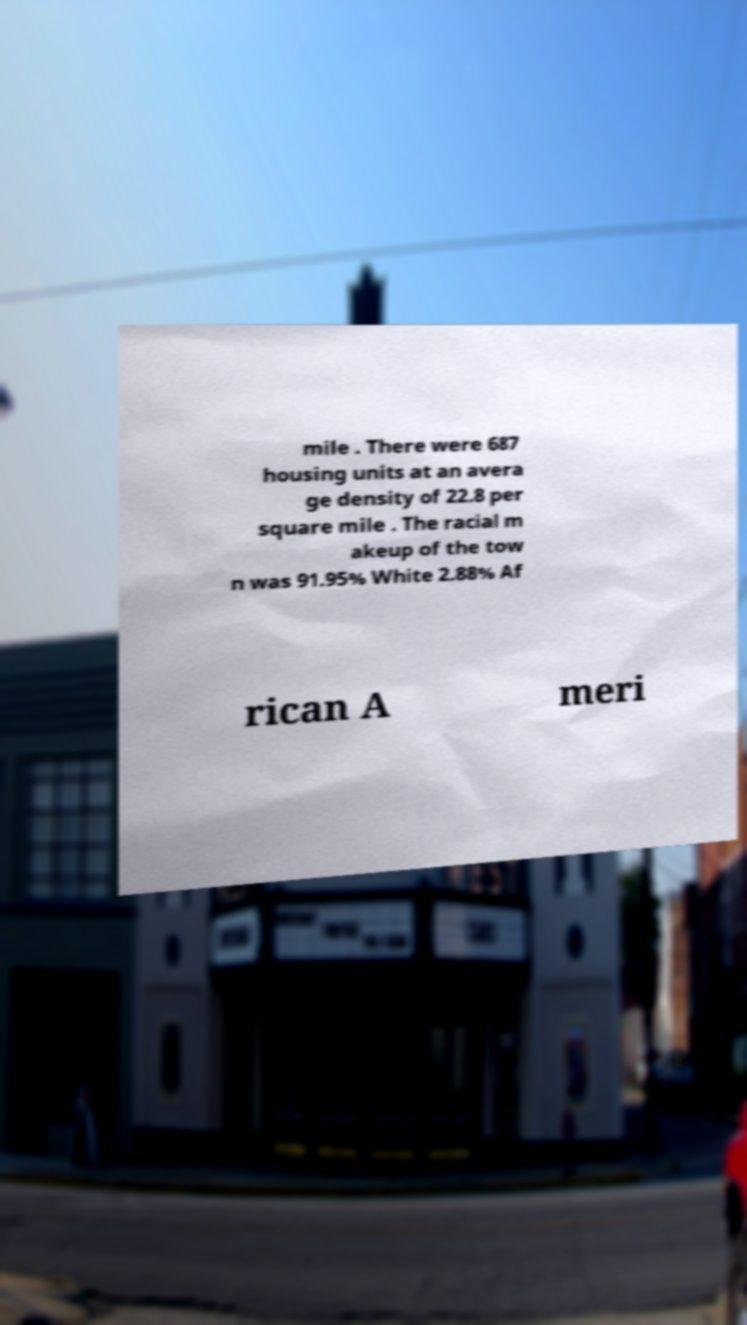Please read and relay the text visible in this image. What does it say? mile . There were 687 housing units at an avera ge density of 22.8 per square mile . The racial m akeup of the tow n was 91.95% White 2.88% Af rican A meri 